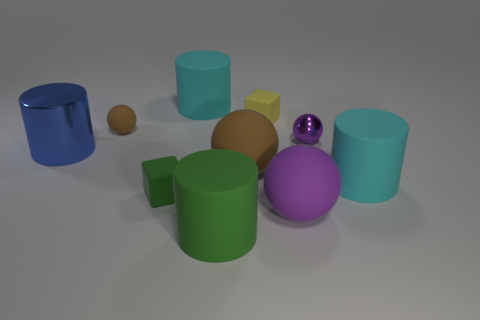What number of objects are either green matte spheres or shiny balls?
Ensure brevity in your answer.  1. There is another purple object that is the same shape as the small metallic thing; what is its size?
Keep it short and to the point. Large. The purple metal sphere is what size?
Keep it short and to the point. Small. Are there more large blue things that are to the right of the tiny yellow cube than large green cylinders?
Provide a succinct answer. No. Is there anything else that has the same material as the big purple object?
Your answer should be very brief. Yes. Does the rubber cylinder that is right of the big purple ball have the same color as the tiny matte object left of the tiny green cube?
Keep it short and to the point. No. There is a blue cylinder that is left of the small object left of the small object that is in front of the small purple thing; what is it made of?
Your response must be concise. Metal. Are there more tiny cyan metallic blocks than tiny yellow matte things?
Make the answer very short. No. Is there anything else that has the same color as the large metal cylinder?
Provide a succinct answer. No. There is a green cylinder that is the same material as the big purple thing; what size is it?
Give a very brief answer. Large. 